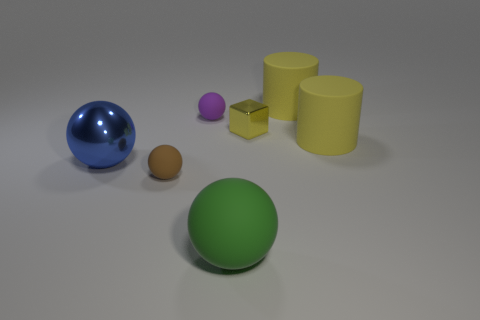What material is the big blue ball that is in front of the tiny object to the right of the green object?
Offer a terse response. Metal. What material is the large thing that is on the left side of the yellow metal cube and behind the large green matte object?
Keep it short and to the point. Metal. Are there an equal number of cylinders that are on the left side of the small purple object and purple rubber objects?
Provide a short and direct response. No. How many large brown metal things have the same shape as the green matte thing?
Your answer should be very brief. 0. How big is the metal object to the left of the ball in front of the tiny rubber ball that is left of the purple object?
Your answer should be very brief. Large. Do the ball that is behind the small shiny block and the green thing have the same material?
Offer a terse response. Yes. Are there the same number of small purple matte objects that are behind the big blue thing and large metallic things that are right of the metal block?
Your answer should be compact. No. There is a blue object that is the same shape as the tiny purple object; what is it made of?
Offer a very short reply. Metal. There is a cylinder that is behind the rubber ball that is behind the small brown thing; are there any things that are left of it?
Provide a short and direct response. Yes. Is the shape of the tiny object right of the green sphere the same as the tiny object that is in front of the big blue metal thing?
Ensure brevity in your answer.  No. 